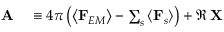<formula> <loc_0><loc_0><loc_500><loc_500>\begin{array} { r l } { A } & \equiv 4 \pi \left ( \left \langle F _ { E M } \right \rangle - \sum _ { s } \left \langle F _ { s } \right \rangle \right ) + \Re \, X } \end{array}</formula> 